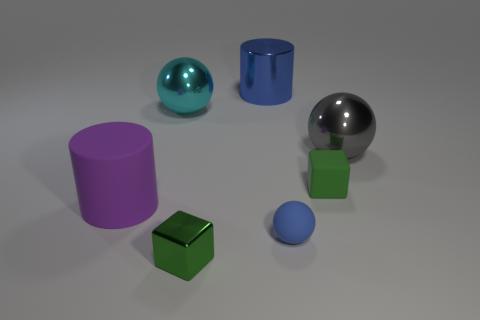Add 1 large purple rubber balls. How many objects exist? 8 Subtract all large spheres. How many spheres are left? 1 Subtract all spheres. How many objects are left? 4 Subtract 1 gray spheres. How many objects are left? 6 Subtract all brown balls. Subtract all brown cylinders. How many balls are left? 3 Subtract all small metal blocks. Subtract all big purple objects. How many objects are left? 5 Add 4 purple matte objects. How many purple matte objects are left? 5 Add 3 small yellow shiny cylinders. How many small yellow shiny cylinders exist? 3 